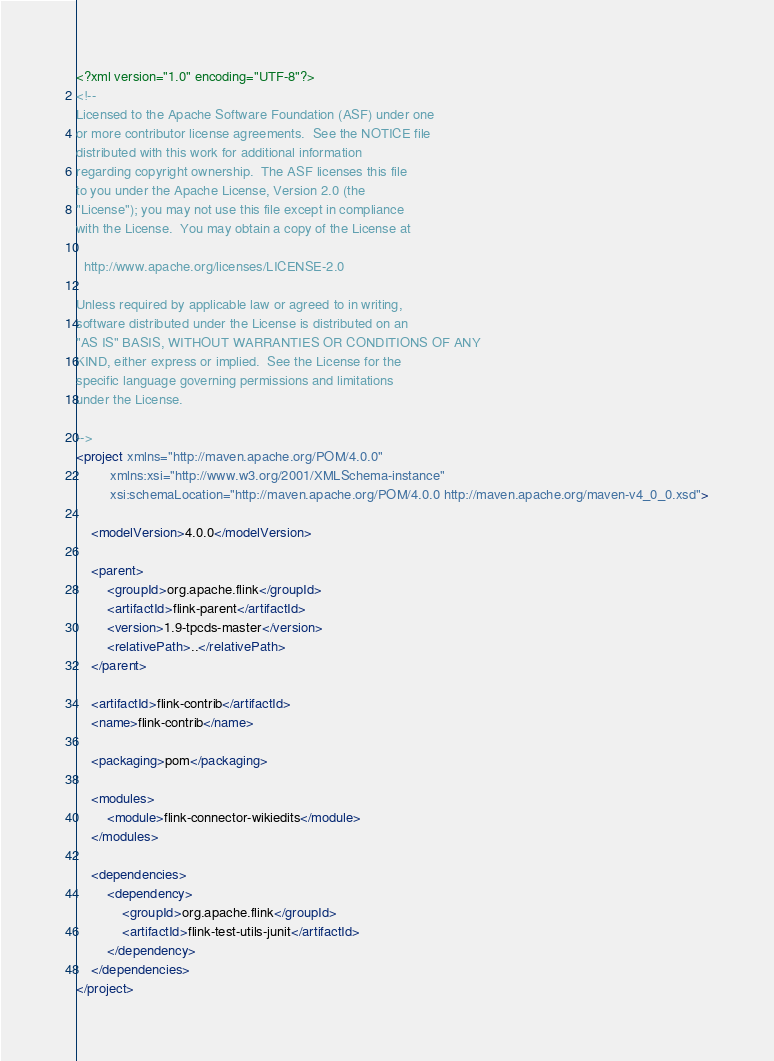Convert code to text. <code><loc_0><loc_0><loc_500><loc_500><_XML_><?xml version="1.0" encoding="UTF-8"?>
<!--
Licensed to the Apache Software Foundation (ASF) under one
or more contributor license agreements.  See the NOTICE file
distributed with this work for additional information
regarding copyright ownership.  The ASF licenses this file
to you under the Apache License, Version 2.0 (the
"License"); you may not use this file except in compliance
with the License.  You may obtain a copy of the License at

  http://www.apache.org/licenses/LICENSE-2.0

Unless required by applicable law or agreed to in writing,
software distributed under the License is distributed on an
"AS IS" BASIS, WITHOUT WARRANTIES OR CONDITIONS OF ANY
KIND, either express or implied.  See the License for the
specific language governing permissions and limitations
under the License.

-->
<project xmlns="http://maven.apache.org/POM/4.0.0"
         xmlns:xsi="http://www.w3.org/2001/XMLSchema-instance"
         xsi:schemaLocation="http://maven.apache.org/POM/4.0.0 http://maven.apache.org/maven-v4_0_0.xsd">

	<modelVersion>4.0.0</modelVersion>

	<parent>
		<groupId>org.apache.flink</groupId>
		<artifactId>flink-parent</artifactId>
		<version>1.9-tpcds-master</version>
		<relativePath>..</relativePath>
	</parent>

	<artifactId>flink-contrib</artifactId>
	<name>flink-contrib</name>

	<packaging>pom</packaging>

	<modules>
		<module>flink-connector-wikiedits</module>
	</modules>

	<dependencies>
		<dependency>
			<groupId>org.apache.flink</groupId>
			<artifactId>flink-test-utils-junit</artifactId>
		</dependency>
	</dependencies>
</project>
</code> 